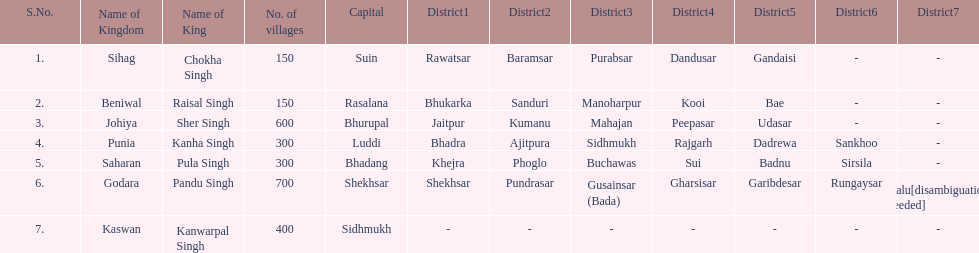How many districts does punia have? 6. 